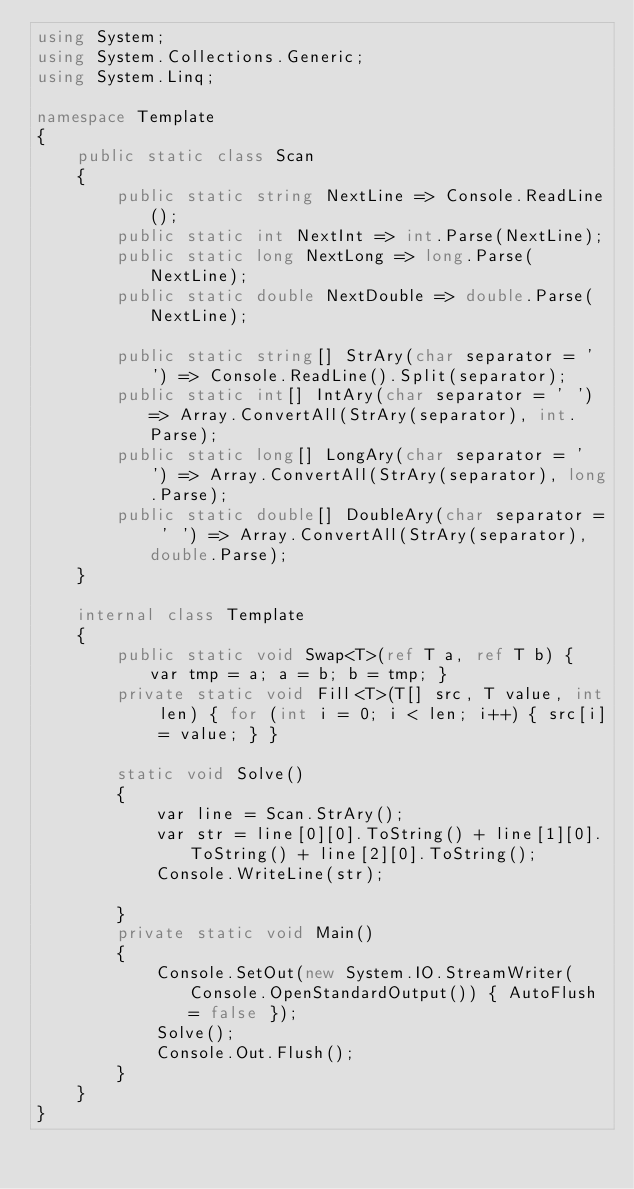<code> <loc_0><loc_0><loc_500><loc_500><_C#_>using System;
using System.Collections.Generic;
using System.Linq;

namespace Template
{
    public static class Scan
    {
        public static string NextLine => Console.ReadLine();
        public static int NextInt => int.Parse(NextLine);
        public static long NextLong => long.Parse(NextLine);
        public static double NextDouble => double.Parse(NextLine);

        public static string[] StrAry(char separator = ' ') => Console.ReadLine().Split(separator);
        public static int[] IntAry(char separator = ' ') => Array.ConvertAll(StrAry(separator), int.Parse);
        public static long[] LongAry(char separator = ' ') => Array.ConvertAll(StrAry(separator), long.Parse);
        public static double[] DoubleAry(char separator = ' ') => Array.ConvertAll(StrAry(separator), double.Parse);
    }

    internal class Template
    {
        public static void Swap<T>(ref T a, ref T b) { var tmp = a; a = b; b = tmp; }
        private static void Fill<T>(T[] src, T value, int len) { for (int i = 0; i < len; i++) { src[i] = value; } }

        static void Solve() 
        {
            var line = Scan.StrAry();
            var str = line[0][0].ToString() + line[1][0].ToString() + line[2][0].ToString();
            Console.WriteLine(str);
            
        }
        private static void Main()
        {
            Console.SetOut(new System.IO.StreamWriter(Console.OpenStandardOutput()) { AutoFlush = false });
            Solve();
            Console.Out.Flush();
        }
    }
}
</code> 